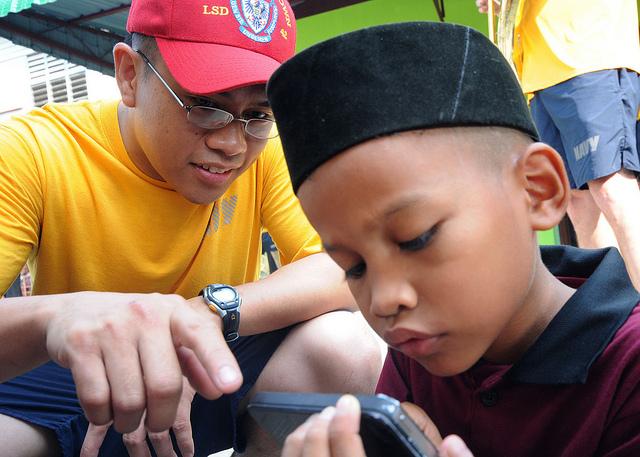What is on the boys wrist?
Write a very short answer. Watch. Is the boy's left ear covered?
Quick response, please. No. What color is the older boy's cap?
Answer briefly. Red. 